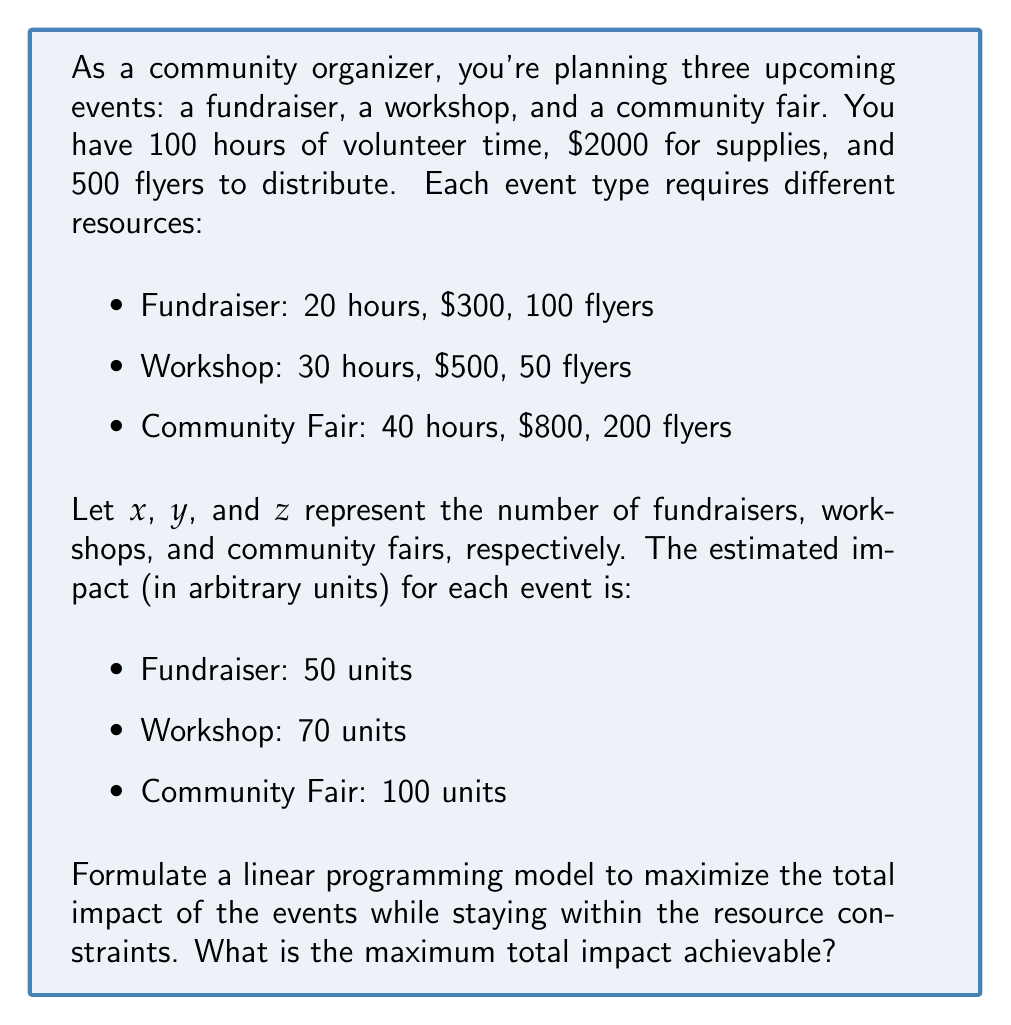What is the answer to this math problem? Let's approach this step-by-step:

1) First, we need to define our objective function. We want to maximize the total impact:

   Maximize: $50x + 70y + 100z$

2) Now, we need to set up our constraints based on the available resources:

   Hours: $20x + 30y + 40z \leq 100$
   Supplies: $300x + 500y + 800z \leq 2000$
   Flyers: $100x + 50y + 200z \leq 500$

3) We also need non-negativity constraints:

   $x \geq 0$, $y \geq 0$, $z \geq 0$

4) Now we have a complete linear programming model. We can solve this using the simplex method or using software. Let's solve it step-by-step using the graphical method, as we have three variables.

5) First, let's consider the flyer constraint, as it's the most restrictive:

   $100x + 50y + 200z \leq 500$

   If we use all flyers for one type of event:
   - Max fundraisers (x): 5
   - Max workshops (y): 10
   - Max community fairs (z): 2.5

6) Looking at the hours constraint:

   $20x + 30y + 40z \leq 100$

   This allows for at most 5 fundraisers, 3.33 workshops, or 2.5 community fairs.

7) The supplies constraint is less restrictive, so we'll focus on the hours and flyers constraints.

8) Given these constraints, a feasible solution that maximizes impact would be:
   2 community fairs (z = 2) and 1 workshop (y = 1)

   This uses:
   - 95 hours (40*2 + 30*1)
   - $2100 in supplies (800*2 + 500*1)
   - 450 flyers (200*2 + 50*1)

9) The total impact of this solution is:

   $100*2 + 70*1 = 270$ units

This is the maximum achievable impact while staying within the resource constraints.
Answer: 270 units 